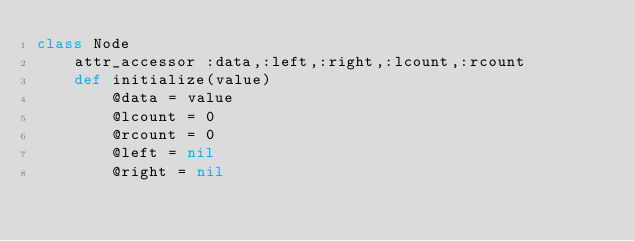Convert code to text. <code><loc_0><loc_0><loc_500><loc_500><_Ruby_>class Node
    attr_accessor :data,:left,:right,:lcount,:rcount
    def initialize(value)
        @data = value
        @lcount = 0
        @rcount = 0
        @left = nil
        @right = nil</code> 